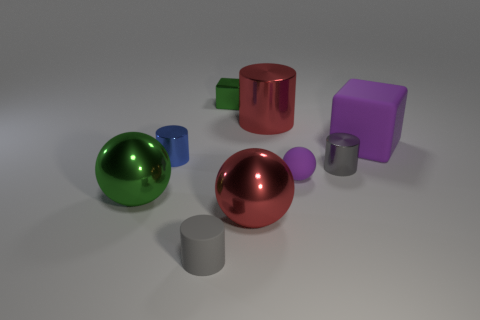Add 1 large brown cubes. How many objects exist? 10 Subtract all blocks. How many objects are left? 7 Add 8 large green shiny balls. How many large green shiny balls exist? 9 Subtract 1 red balls. How many objects are left? 8 Subtract all rubber blocks. Subtract all blue objects. How many objects are left? 7 Add 1 big matte things. How many big matte things are left? 2 